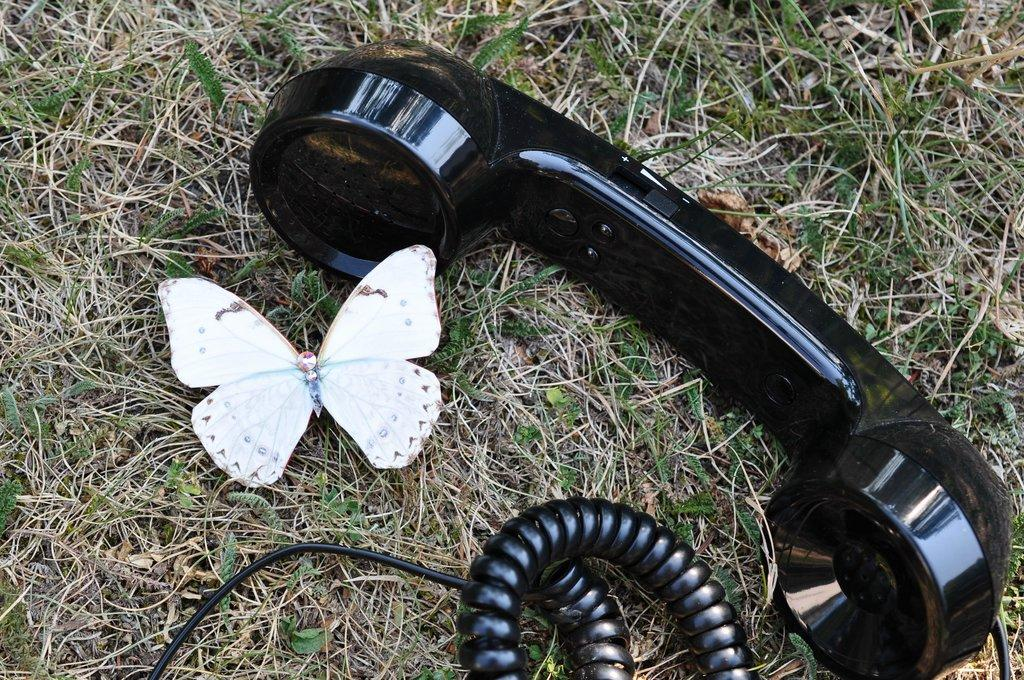What type of telephone can be seen in the image? There is a black colored telephone in the image. What is connected to the telephone in the image? There is a telephone wire on the ground in the image. What other living creature is present in the image? There is a white colored butterfly in the image. What type of terrain is visible in the image? There is grass on the ground in the image. What type of bread is being used to rake the grass in the image? There is no bread or rake present in the image. 